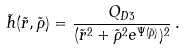Convert formula to latex. <formula><loc_0><loc_0><loc_500><loc_500>\tilde { h } ( \tilde { r } , \tilde { \rho } ) = \frac { Q _ { D 3 } } { ( \tilde { r } ^ { 2 } + \tilde { \rho } ^ { 2 } e ^ { \Psi ( \tilde { \rho } ) } ) ^ { 2 } } \, .</formula> 